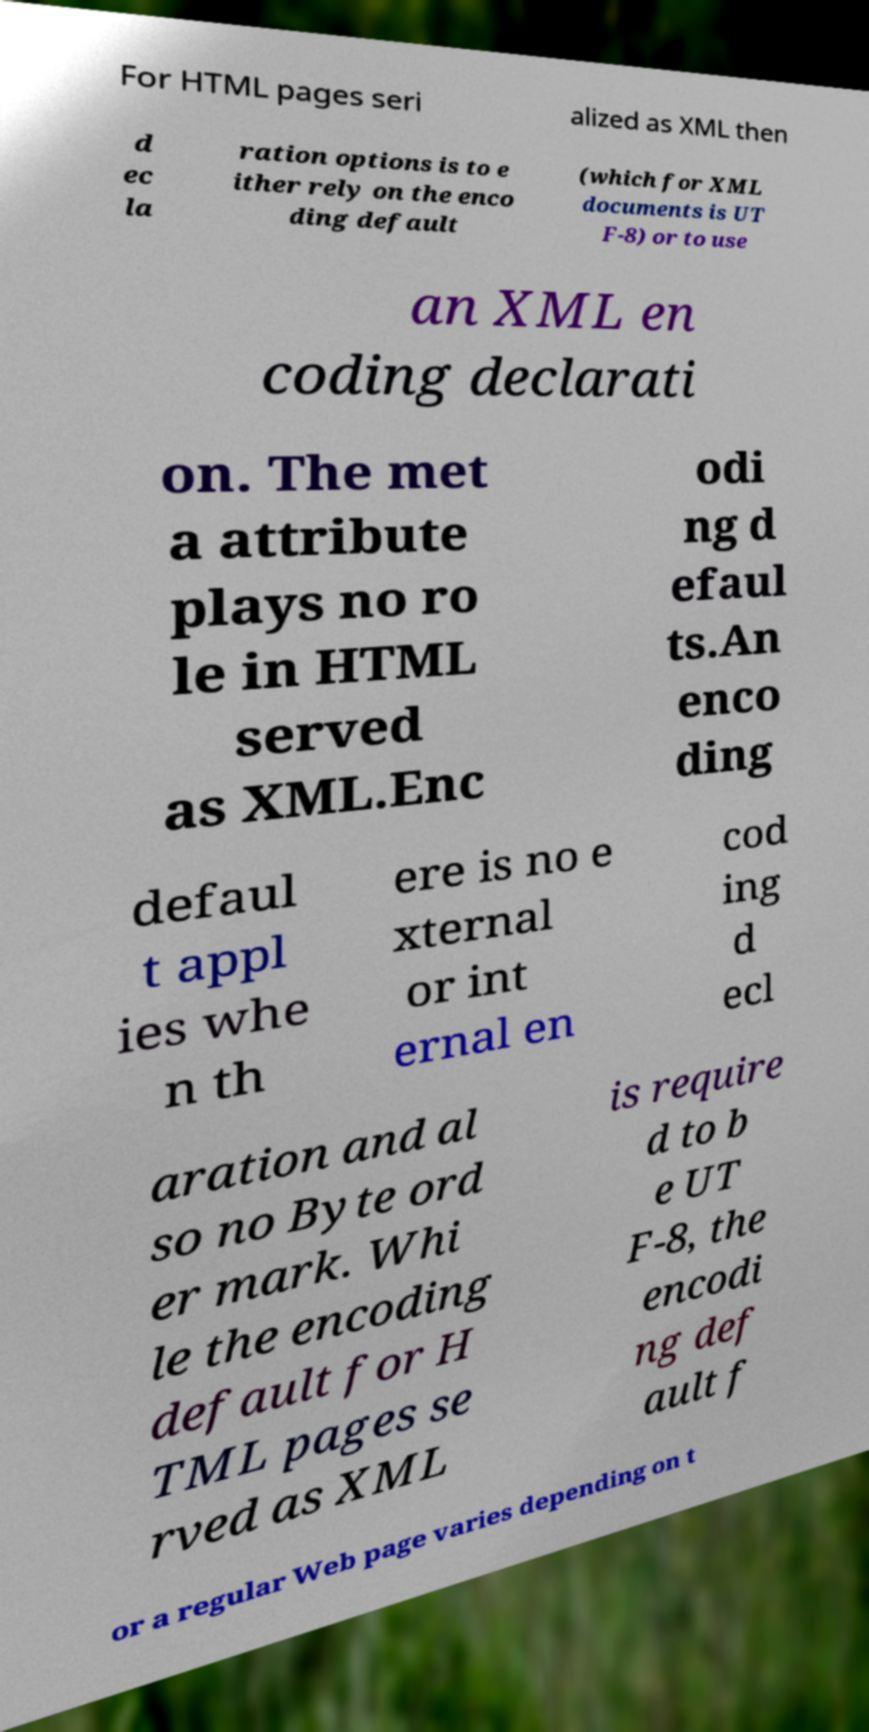For documentation purposes, I need the text within this image transcribed. Could you provide that? For HTML pages seri alized as XML then d ec la ration options is to e ither rely on the enco ding default (which for XML documents is UT F-8) or to use an XML en coding declarati on. The met a attribute plays no ro le in HTML served as XML.Enc odi ng d efaul ts.An enco ding defaul t appl ies whe n th ere is no e xternal or int ernal en cod ing d ecl aration and al so no Byte ord er mark. Whi le the encoding default for H TML pages se rved as XML is require d to b e UT F-8, the encodi ng def ault f or a regular Web page varies depending on t 